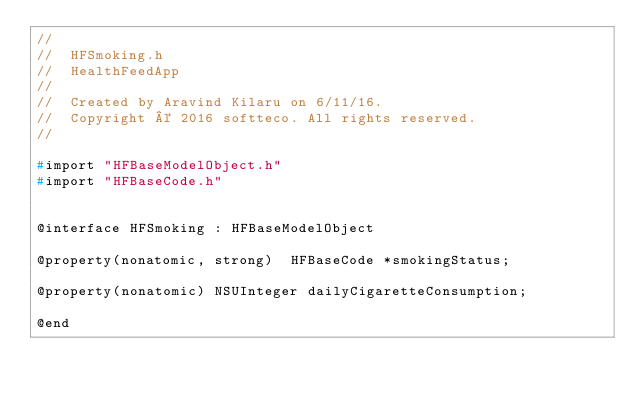<code> <loc_0><loc_0><loc_500><loc_500><_C_>//
//  HFSmoking.h
//  HealthFeedApp
//
//  Created by Aravind Kilaru on 6/11/16.
//  Copyright © 2016 softteco. All rights reserved.
//

#import "HFBaseModelObject.h"
#import "HFBaseCode.h"


@interface HFSmoking : HFBaseModelObject

@property(nonatomic, strong)  HFBaseCode *smokingStatus;

@property(nonatomic) NSUInteger dailyCigaretteConsumption;

@end
</code> 